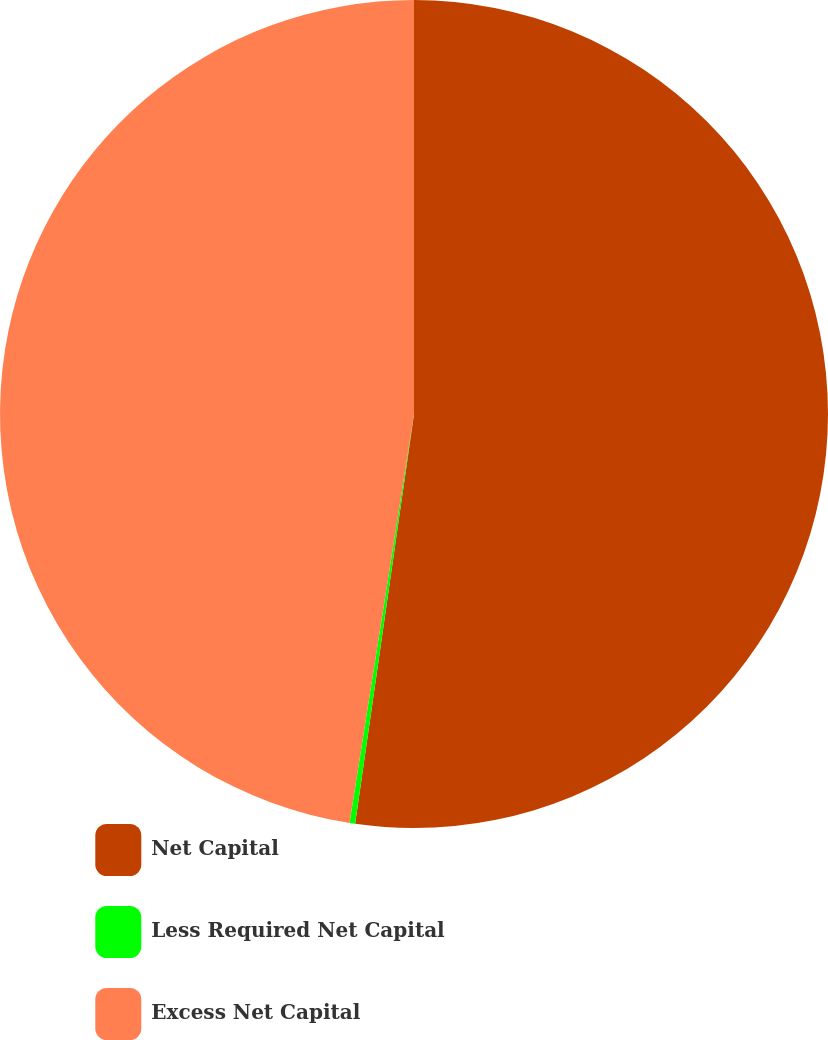Convert chart to OTSL. <chart><loc_0><loc_0><loc_500><loc_500><pie_chart><fcel>Net Capital<fcel>Less Required Net Capital<fcel>Excess Net Capital<nl><fcel>52.27%<fcel>0.22%<fcel>47.51%<nl></chart> 